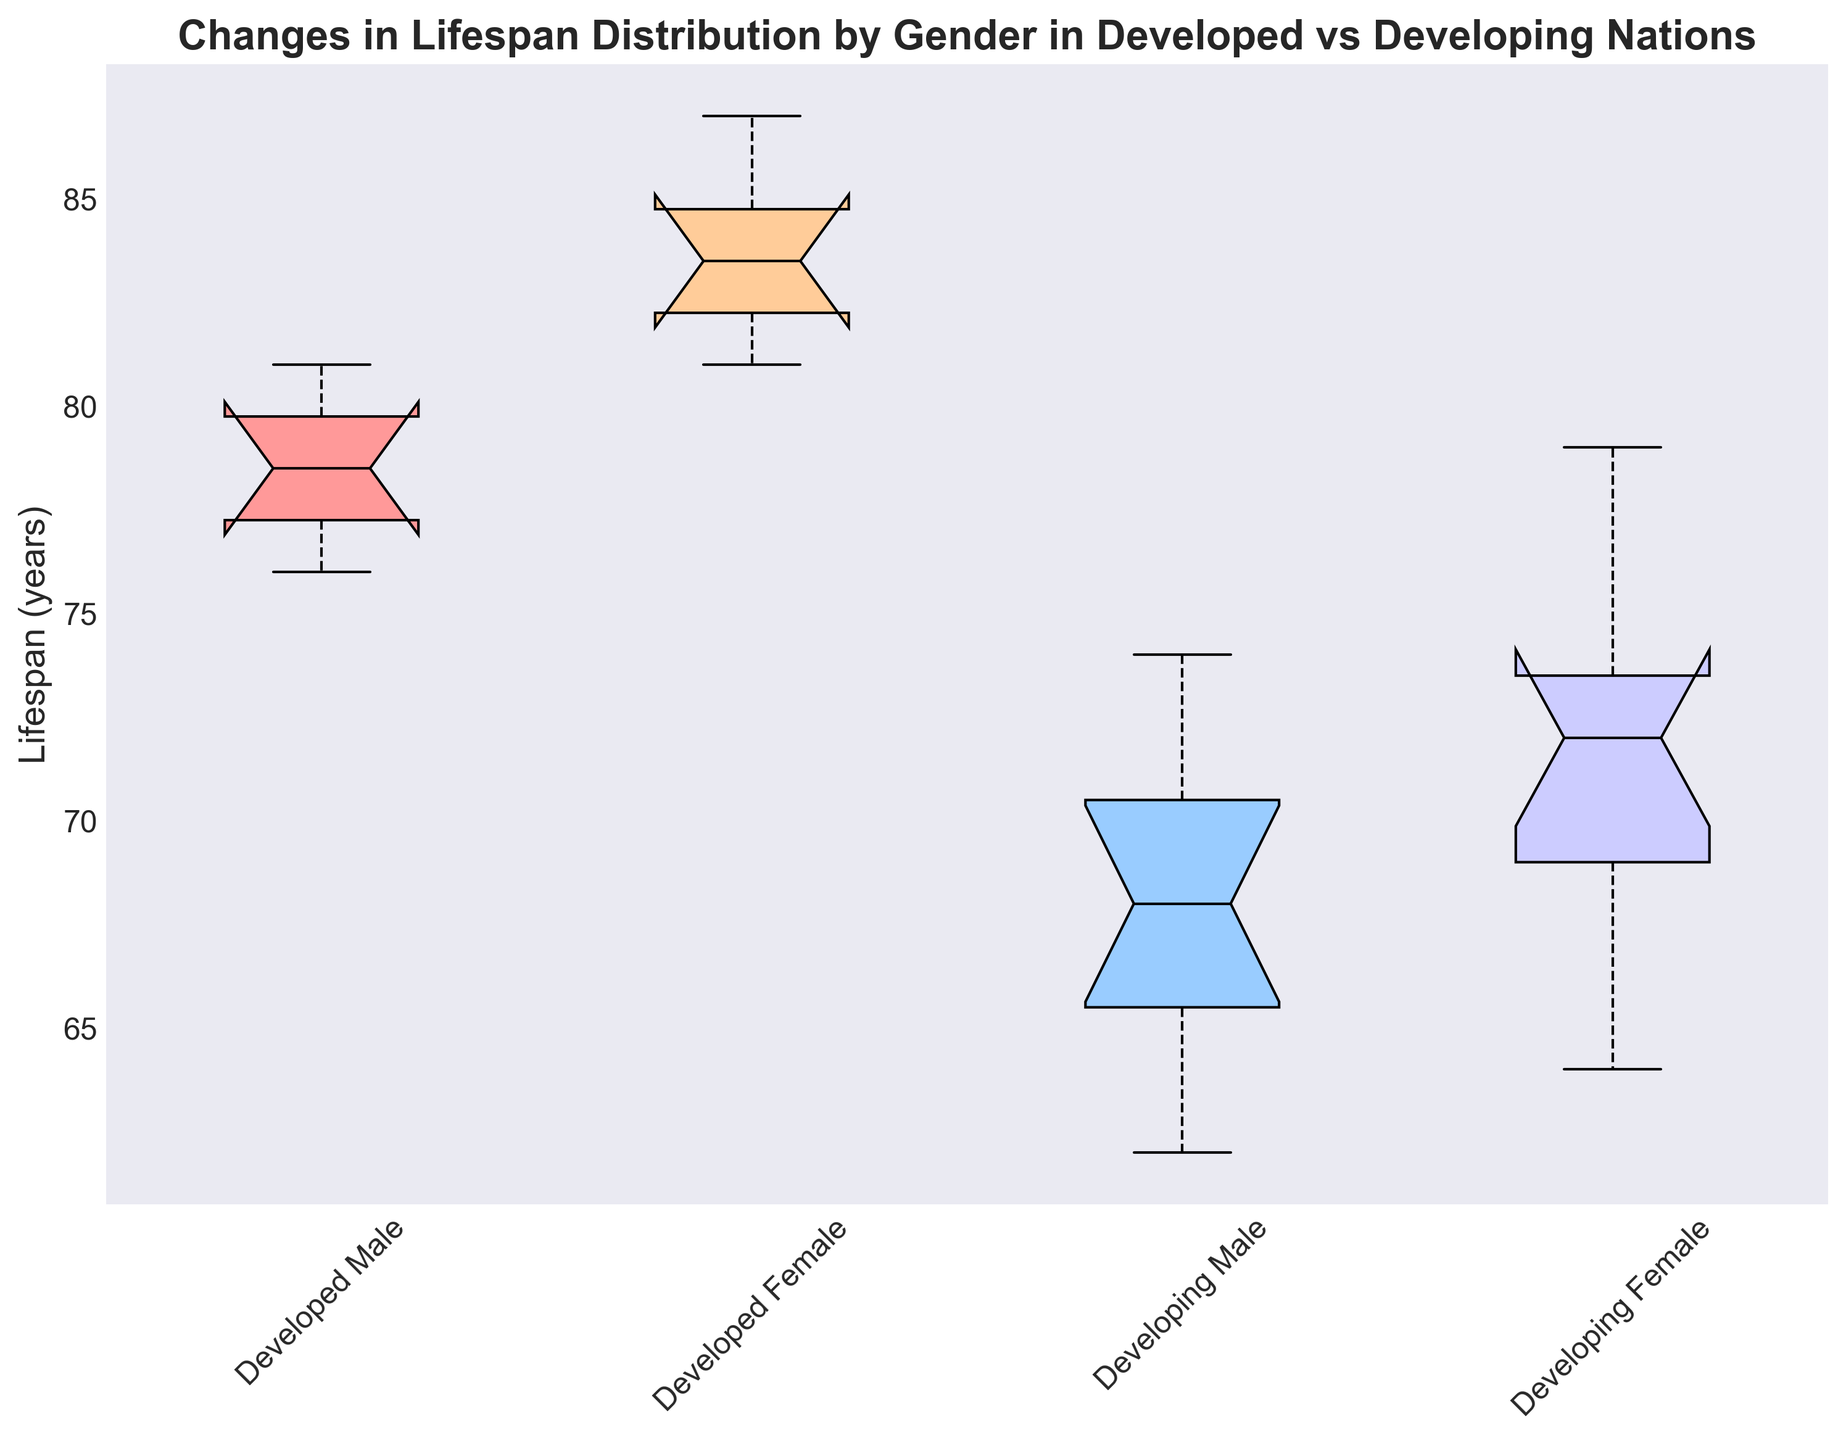Which group has the highest median lifespan? To determine the group with the highest median lifespan, we refer to the horizontal line inside each box plot. The median line in the "Developed Female" box is the highest among all groups.
Answer: Developed Female What is the approximate difference in the median lifespan between Developed Females and Developing Males? The median lifespan for Developed Females is about 84 years and for Developing Males is about 68 years. The difference is 84 - 68.
Answer: 16 years How does the range of lifespan for Developed Males compare to that of Developing Females? The range is the difference between the maximum and minimum whisker points. Developed Males appear to have a range from 76 to 81 (5 years), while Developing Females range from 64 to 79 (15 years).
Answer: Developed Males have a smaller range Which group shows the smallest interquartile range (IQR)? The interquartile range (IQR) is the height of the box, representing the middle 50% of the data. Developed Males have the smallest IQR with a tight box from approximately 77 to 80.
Answer: Developed Males Between Developing Males and Developing Females, which group has a higher upper whisker? The upper whisker represents the maximum lifespan excluding outliers. Technical reasoning sees Developing Females with a higher whisker extending upwards to around 79 compared to Developing Males, which extends to about 74.
Answer: Developing Females What can be inferred about the lifespan variability in Developing Nations compared to Developed Nations, taking gender into account? Developed Nations show tighter, more consistent IQRs and whiskers, indicating less variability. Developing Nations have larger IQRs and whiskers, suggesting higher variability in lifespans.
Answer: Developed Nations have less variability In which group is the lower quartile closest to the overall median lifespan across all groups? The overall median across all groups visually seems close to 75 years. Developed Males show a lower quartile close to this value, with a first quartile around 77 years.
Answer: Developed Males How do the lifespans of Developed Females compare visually to those of Developing Males? Developed Females have higher medians, higher upper whiskers, and overall higher quartiles compared to Developing Males, visually demonstrating a significantly higher lifespan distribution.
Answer: Developed Females have higher lifespans 